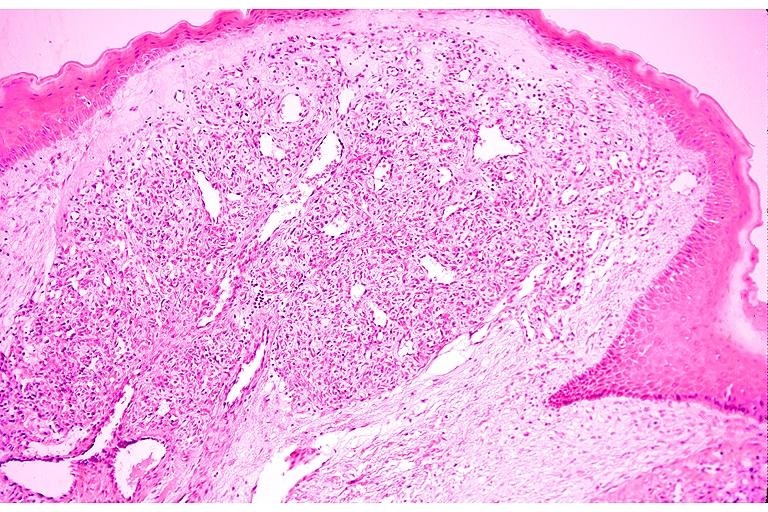does intraductal papillomatosis with apocrine metaplasia show capillary hemangioma?
Answer the question using a single word or phrase. No 